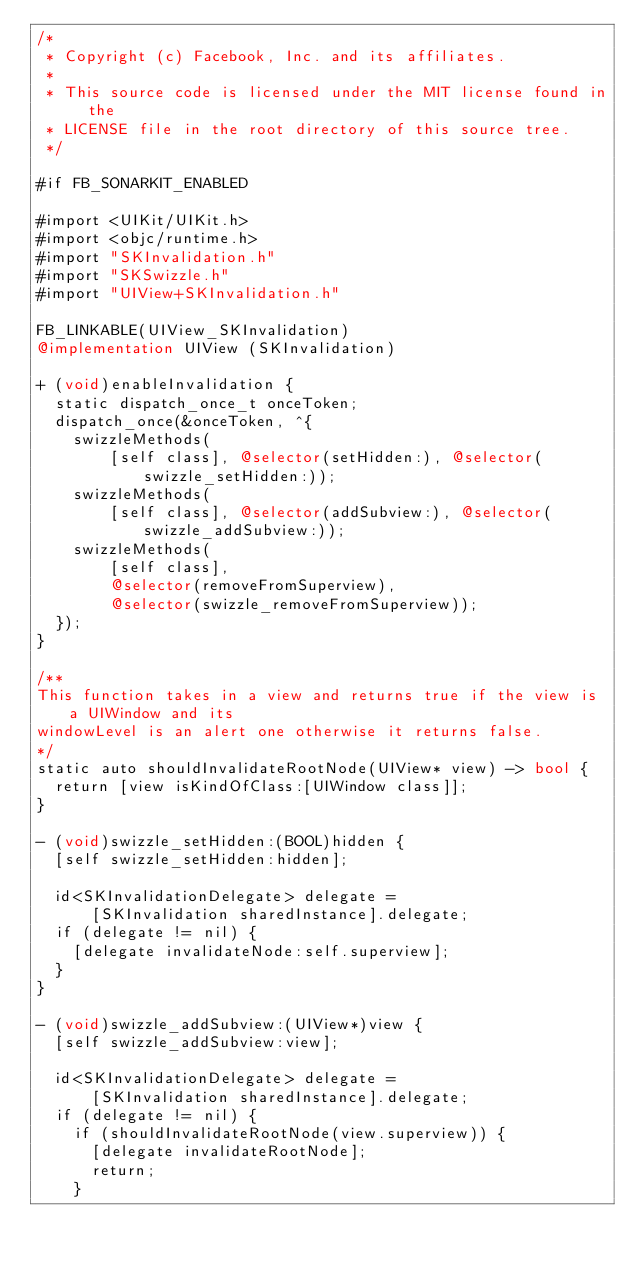Convert code to text. <code><loc_0><loc_0><loc_500><loc_500><_ObjectiveC_>/*
 * Copyright (c) Facebook, Inc. and its affiliates.
 *
 * This source code is licensed under the MIT license found in the
 * LICENSE file in the root directory of this source tree.
 */

#if FB_SONARKIT_ENABLED

#import <UIKit/UIKit.h>
#import <objc/runtime.h>
#import "SKInvalidation.h"
#import "SKSwizzle.h"
#import "UIView+SKInvalidation.h"

FB_LINKABLE(UIView_SKInvalidation)
@implementation UIView (SKInvalidation)

+ (void)enableInvalidation {
  static dispatch_once_t onceToken;
  dispatch_once(&onceToken, ^{
    swizzleMethods(
        [self class], @selector(setHidden:), @selector(swizzle_setHidden:));
    swizzleMethods(
        [self class], @selector(addSubview:), @selector(swizzle_addSubview:));
    swizzleMethods(
        [self class],
        @selector(removeFromSuperview),
        @selector(swizzle_removeFromSuperview));
  });
}

/**
This function takes in a view and returns true if the view is a UIWindow and its
windowLevel is an alert one otherwise it returns false.
*/
static auto shouldInvalidateRootNode(UIView* view) -> bool {
  return [view isKindOfClass:[UIWindow class]];
}

- (void)swizzle_setHidden:(BOOL)hidden {
  [self swizzle_setHidden:hidden];

  id<SKInvalidationDelegate> delegate =
      [SKInvalidation sharedInstance].delegate;
  if (delegate != nil) {
    [delegate invalidateNode:self.superview];
  }
}

- (void)swizzle_addSubview:(UIView*)view {
  [self swizzle_addSubview:view];

  id<SKInvalidationDelegate> delegate =
      [SKInvalidation sharedInstance].delegate;
  if (delegate != nil) {
    if (shouldInvalidateRootNode(view.superview)) {
      [delegate invalidateRootNode];
      return;
    }</code> 